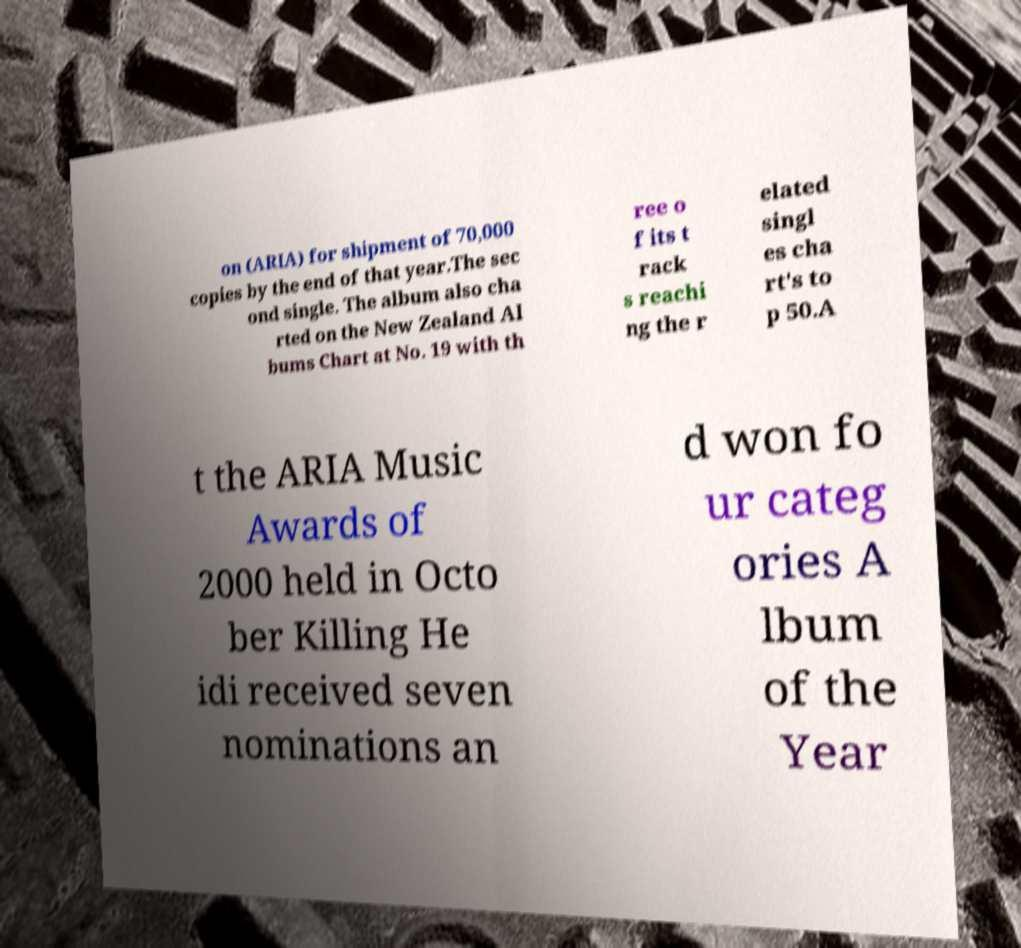For documentation purposes, I need the text within this image transcribed. Could you provide that? on (ARIA) for shipment of 70,000 copies by the end of that year.The sec ond single. The album also cha rted on the New Zealand Al bums Chart at No. 19 with th ree o f its t rack s reachi ng the r elated singl es cha rt's to p 50.A t the ARIA Music Awards of 2000 held in Octo ber Killing He idi received seven nominations an d won fo ur categ ories A lbum of the Year 